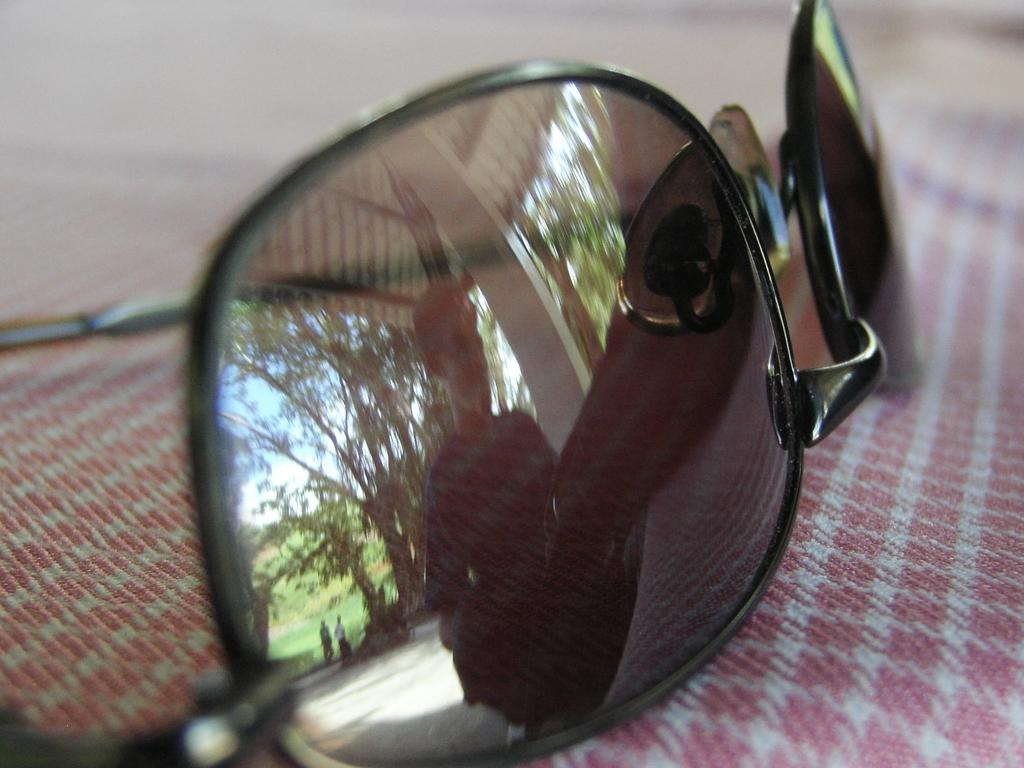What type of eyewear is present in the image? There is a pair of black goggles in the image. What is the goggles placed on? The goggles are placed on a cloth. What type of line is visible on the goggles in the image? There is no line visible on the goggles in the image. Where is the bucket located in the image? There is no bucket present in the image. 